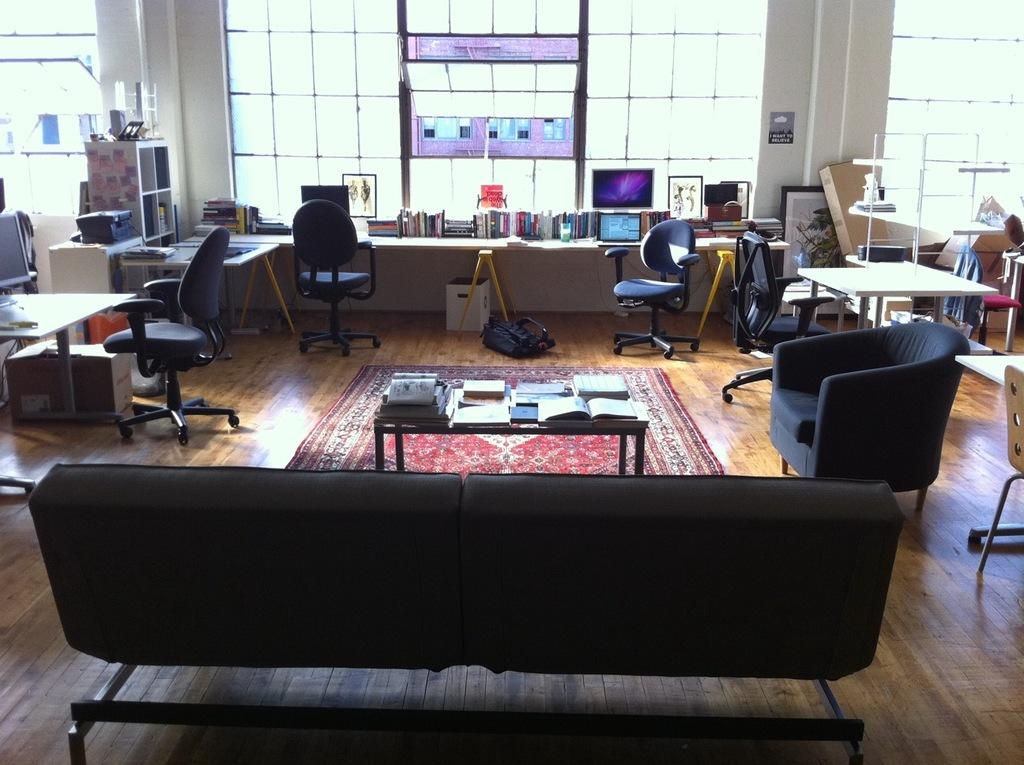What type of furniture is present in the image? There is a chair in the image. What items can be seen on the furniture or nearby? There are books and a table in the image. What type of flooring is visible in the image? There is a carpet in the image. What type of storage or organization item is present in the image? There is a rack in the image. What type of container is present in the image? There is a box in the image. Can you tell me how fast the grandfather is running in the image? There is no grandfather or running depicted in the image. What color is the nose of the person in the image? There is no person present in the image, and therefore no nose to describe. 